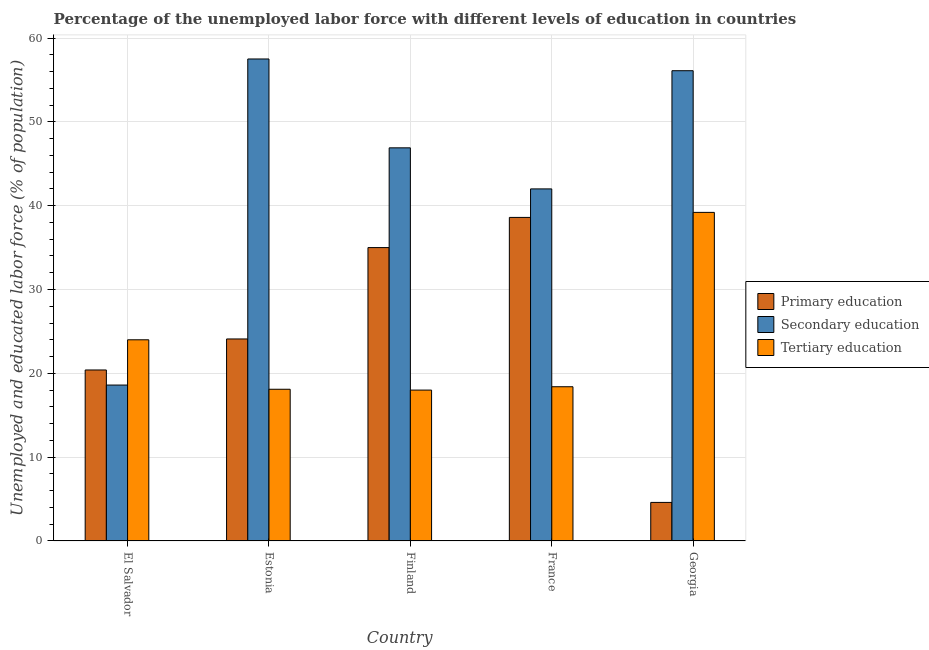Are the number of bars per tick equal to the number of legend labels?
Offer a very short reply. Yes. Are the number of bars on each tick of the X-axis equal?
Keep it short and to the point. Yes. How many bars are there on the 5th tick from the left?
Make the answer very short. 3. What is the label of the 1st group of bars from the left?
Give a very brief answer. El Salvador. What is the percentage of labor force who received secondary education in Georgia?
Provide a succinct answer. 56.1. Across all countries, what is the maximum percentage of labor force who received primary education?
Your answer should be compact. 38.6. In which country was the percentage of labor force who received primary education maximum?
Your response must be concise. France. In which country was the percentage of labor force who received tertiary education minimum?
Your answer should be very brief. Finland. What is the total percentage of labor force who received tertiary education in the graph?
Your response must be concise. 117.7. What is the difference between the percentage of labor force who received tertiary education in Estonia and that in Finland?
Your response must be concise. 0.1. What is the difference between the percentage of labor force who received secondary education in Georgia and the percentage of labor force who received primary education in France?
Give a very brief answer. 17.5. What is the average percentage of labor force who received tertiary education per country?
Your answer should be very brief. 23.54. What is the difference between the percentage of labor force who received secondary education and percentage of labor force who received tertiary education in Georgia?
Ensure brevity in your answer.  16.9. What is the ratio of the percentage of labor force who received secondary education in Estonia to that in France?
Provide a short and direct response. 1.37. What is the difference between the highest and the second highest percentage of labor force who received tertiary education?
Make the answer very short. 15.2. What is the difference between the highest and the lowest percentage of labor force who received tertiary education?
Offer a very short reply. 21.2. In how many countries, is the percentage of labor force who received secondary education greater than the average percentage of labor force who received secondary education taken over all countries?
Your answer should be very brief. 3. What does the 1st bar from the left in Georgia represents?
Make the answer very short. Primary education. Are all the bars in the graph horizontal?
Offer a very short reply. No. How many countries are there in the graph?
Provide a short and direct response. 5. What is the difference between two consecutive major ticks on the Y-axis?
Provide a succinct answer. 10. What is the title of the graph?
Your answer should be very brief. Percentage of the unemployed labor force with different levels of education in countries. Does "Profit Tax" appear as one of the legend labels in the graph?
Your response must be concise. No. What is the label or title of the X-axis?
Give a very brief answer. Country. What is the label or title of the Y-axis?
Provide a succinct answer. Unemployed and educated labor force (% of population). What is the Unemployed and educated labor force (% of population) in Primary education in El Salvador?
Keep it short and to the point. 20.4. What is the Unemployed and educated labor force (% of population) of Secondary education in El Salvador?
Provide a short and direct response. 18.6. What is the Unemployed and educated labor force (% of population) of Tertiary education in El Salvador?
Keep it short and to the point. 24. What is the Unemployed and educated labor force (% of population) in Primary education in Estonia?
Your answer should be very brief. 24.1. What is the Unemployed and educated labor force (% of population) of Secondary education in Estonia?
Provide a short and direct response. 57.5. What is the Unemployed and educated labor force (% of population) in Tertiary education in Estonia?
Offer a terse response. 18.1. What is the Unemployed and educated labor force (% of population) of Primary education in Finland?
Your answer should be compact. 35. What is the Unemployed and educated labor force (% of population) in Secondary education in Finland?
Your response must be concise. 46.9. What is the Unemployed and educated labor force (% of population) of Primary education in France?
Give a very brief answer. 38.6. What is the Unemployed and educated labor force (% of population) in Secondary education in France?
Your answer should be very brief. 42. What is the Unemployed and educated labor force (% of population) in Tertiary education in France?
Keep it short and to the point. 18.4. What is the Unemployed and educated labor force (% of population) of Primary education in Georgia?
Keep it short and to the point. 4.6. What is the Unemployed and educated labor force (% of population) in Secondary education in Georgia?
Offer a terse response. 56.1. What is the Unemployed and educated labor force (% of population) in Tertiary education in Georgia?
Provide a succinct answer. 39.2. Across all countries, what is the maximum Unemployed and educated labor force (% of population) in Primary education?
Keep it short and to the point. 38.6. Across all countries, what is the maximum Unemployed and educated labor force (% of population) in Secondary education?
Your response must be concise. 57.5. Across all countries, what is the maximum Unemployed and educated labor force (% of population) of Tertiary education?
Give a very brief answer. 39.2. Across all countries, what is the minimum Unemployed and educated labor force (% of population) of Primary education?
Offer a terse response. 4.6. Across all countries, what is the minimum Unemployed and educated labor force (% of population) in Secondary education?
Offer a very short reply. 18.6. Across all countries, what is the minimum Unemployed and educated labor force (% of population) in Tertiary education?
Offer a very short reply. 18. What is the total Unemployed and educated labor force (% of population) in Primary education in the graph?
Your answer should be compact. 122.7. What is the total Unemployed and educated labor force (% of population) of Secondary education in the graph?
Ensure brevity in your answer.  221.1. What is the total Unemployed and educated labor force (% of population) of Tertiary education in the graph?
Provide a succinct answer. 117.7. What is the difference between the Unemployed and educated labor force (% of population) in Primary education in El Salvador and that in Estonia?
Your response must be concise. -3.7. What is the difference between the Unemployed and educated labor force (% of population) of Secondary education in El Salvador and that in Estonia?
Give a very brief answer. -38.9. What is the difference between the Unemployed and educated labor force (% of population) of Tertiary education in El Salvador and that in Estonia?
Ensure brevity in your answer.  5.9. What is the difference between the Unemployed and educated labor force (% of population) of Primary education in El Salvador and that in Finland?
Ensure brevity in your answer.  -14.6. What is the difference between the Unemployed and educated labor force (% of population) of Secondary education in El Salvador and that in Finland?
Provide a short and direct response. -28.3. What is the difference between the Unemployed and educated labor force (% of population) in Primary education in El Salvador and that in France?
Make the answer very short. -18.2. What is the difference between the Unemployed and educated labor force (% of population) in Secondary education in El Salvador and that in France?
Keep it short and to the point. -23.4. What is the difference between the Unemployed and educated labor force (% of population) in Primary education in El Salvador and that in Georgia?
Ensure brevity in your answer.  15.8. What is the difference between the Unemployed and educated labor force (% of population) of Secondary education in El Salvador and that in Georgia?
Your answer should be very brief. -37.5. What is the difference between the Unemployed and educated labor force (% of population) in Tertiary education in El Salvador and that in Georgia?
Keep it short and to the point. -15.2. What is the difference between the Unemployed and educated labor force (% of population) of Primary education in Estonia and that in Finland?
Your answer should be very brief. -10.9. What is the difference between the Unemployed and educated labor force (% of population) of Secondary education in Estonia and that in France?
Your answer should be very brief. 15.5. What is the difference between the Unemployed and educated labor force (% of population) of Tertiary education in Estonia and that in France?
Your answer should be very brief. -0.3. What is the difference between the Unemployed and educated labor force (% of population) in Primary education in Estonia and that in Georgia?
Your response must be concise. 19.5. What is the difference between the Unemployed and educated labor force (% of population) of Tertiary education in Estonia and that in Georgia?
Give a very brief answer. -21.1. What is the difference between the Unemployed and educated labor force (% of population) in Secondary education in Finland and that in France?
Provide a short and direct response. 4.9. What is the difference between the Unemployed and educated labor force (% of population) of Tertiary education in Finland and that in France?
Provide a succinct answer. -0.4. What is the difference between the Unemployed and educated labor force (% of population) of Primary education in Finland and that in Georgia?
Your response must be concise. 30.4. What is the difference between the Unemployed and educated labor force (% of population) in Tertiary education in Finland and that in Georgia?
Your response must be concise. -21.2. What is the difference between the Unemployed and educated labor force (% of population) of Primary education in France and that in Georgia?
Your answer should be very brief. 34. What is the difference between the Unemployed and educated labor force (% of population) of Secondary education in France and that in Georgia?
Ensure brevity in your answer.  -14.1. What is the difference between the Unemployed and educated labor force (% of population) of Tertiary education in France and that in Georgia?
Your response must be concise. -20.8. What is the difference between the Unemployed and educated labor force (% of population) in Primary education in El Salvador and the Unemployed and educated labor force (% of population) in Secondary education in Estonia?
Offer a terse response. -37.1. What is the difference between the Unemployed and educated labor force (% of population) of Secondary education in El Salvador and the Unemployed and educated labor force (% of population) of Tertiary education in Estonia?
Provide a succinct answer. 0.5. What is the difference between the Unemployed and educated labor force (% of population) of Primary education in El Salvador and the Unemployed and educated labor force (% of population) of Secondary education in Finland?
Your answer should be compact. -26.5. What is the difference between the Unemployed and educated labor force (% of population) of Primary education in El Salvador and the Unemployed and educated labor force (% of population) of Secondary education in France?
Make the answer very short. -21.6. What is the difference between the Unemployed and educated labor force (% of population) of Primary education in El Salvador and the Unemployed and educated labor force (% of population) of Secondary education in Georgia?
Provide a short and direct response. -35.7. What is the difference between the Unemployed and educated labor force (% of population) of Primary education in El Salvador and the Unemployed and educated labor force (% of population) of Tertiary education in Georgia?
Keep it short and to the point. -18.8. What is the difference between the Unemployed and educated labor force (% of population) of Secondary education in El Salvador and the Unemployed and educated labor force (% of population) of Tertiary education in Georgia?
Provide a short and direct response. -20.6. What is the difference between the Unemployed and educated labor force (% of population) in Primary education in Estonia and the Unemployed and educated labor force (% of population) in Secondary education in Finland?
Your answer should be compact. -22.8. What is the difference between the Unemployed and educated labor force (% of population) in Secondary education in Estonia and the Unemployed and educated labor force (% of population) in Tertiary education in Finland?
Offer a terse response. 39.5. What is the difference between the Unemployed and educated labor force (% of population) of Primary education in Estonia and the Unemployed and educated labor force (% of population) of Secondary education in France?
Give a very brief answer. -17.9. What is the difference between the Unemployed and educated labor force (% of population) of Secondary education in Estonia and the Unemployed and educated labor force (% of population) of Tertiary education in France?
Your answer should be compact. 39.1. What is the difference between the Unemployed and educated labor force (% of population) of Primary education in Estonia and the Unemployed and educated labor force (% of population) of Secondary education in Georgia?
Offer a very short reply. -32. What is the difference between the Unemployed and educated labor force (% of population) in Primary education in Estonia and the Unemployed and educated labor force (% of population) in Tertiary education in Georgia?
Keep it short and to the point. -15.1. What is the difference between the Unemployed and educated labor force (% of population) of Secondary education in Estonia and the Unemployed and educated labor force (% of population) of Tertiary education in Georgia?
Offer a very short reply. 18.3. What is the difference between the Unemployed and educated labor force (% of population) of Secondary education in Finland and the Unemployed and educated labor force (% of population) of Tertiary education in France?
Provide a succinct answer. 28.5. What is the difference between the Unemployed and educated labor force (% of population) of Primary education in Finland and the Unemployed and educated labor force (% of population) of Secondary education in Georgia?
Keep it short and to the point. -21.1. What is the difference between the Unemployed and educated labor force (% of population) of Primary education in Finland and the Unemployed and educated labor force (% of population) of Tertiary education in Georgia?
Make the answer very short. -4.2. What is the difference between the Unemployed and educated labor force (% of population) in Secondary education in Finland and the Unemployed and educated labor force (% of population) in Tertiary education in Georgia?
Provide a succinct answer. 7.7. What is the difference between the Unemployed and educated labor force (% of population) in Primary education in France and the Unemployed and educated labor force (% of population) in Secondary education in Georgia?
Provide a succinct answer. -17.5. What is the average Unemployed and educated labor force (% of population) in Primary education per country?
Your response must be concise. 24.54. What is the average Unemployed and educated labor force (% of population) of Secondary education per country?
Provide a succinct answer. 44.22. What is the average Unemployed and educated labor force (% of population) in Tertiary education per country?
Provide a short and direct response. 23.54. What is the difference between the Unemployed and educated labor force (% of population) in Primary education and Unemployed and educated labor force (% of population) in Secondary education in El Salvador?
Your response must be concise. 1.8. What is the difference between the Unemployed and educated labor force (% of population) of Primary education and Unemployed and educated labor force (% of population) of Tertiary education in El Salvador?
Your response must be concise. -3.6. What is the difference between the Unemployed and educated labor force (% of population) in Secondary education and Unemployed and educated labor force (% of population) in Tertiary education in El Salvador?
Your answer should be very brief. -5.4. What is the difference between the Unemployed and educated labor force (% of population) in Primary education and Unemployed and educated labor force (% of population) in Secondary education in Estonia?
Your answer should be very brief. -33.4. What is the difference between the Unemployed and educated labor force (% of population) in Secondary education and Unemployed and educated labor force (% of population) in Tertiary education in Estonia?
Give a very brief answer. 39.4. What is the difference between the Unemployed and educated labor force (% of population) of Secondary education and Unemployed and educated labor force (% of population) of Tertiary education in Finland?
Give a very brief answer. 28.9. What is the difference between the Unemployed and educated labor force (% of population) in Primary education and Unemployed and educated labor force (% of population) in Secondary education in France?
Provide a short and direct response. -3.4. What is the difference between the Unemployed and educated labor force (% of population) of Primary education and Unemployed and educated labor force (% of population) of Tertiary education in France?
Provide a short and direct response. 20.2. What is the difference between the Unemployed and educated labor force (% of population) of Secondary education and Unemployed and educated labor force (% of population) of Tertiary education in France?
Your answer should be very brief. 23.6. What is the difference between the Unemployed and educated labor force (% of population) in Primary education and Unemployed and educated labor force (% of population) in Secondary education in Georgia?
Make the answer very short. -51.5. What is the difference between the Unemployed and educated labor force (% of population) in Primary education and Unemployed and educated labor force (% of population) in Tertiary education in Georgia?
Provide a succinct answer. -34.6. What is the difference between the Unemployed and educated labor force (% of population) of Secondary education and Unemployed and educated labor force (% of population) of Tertiary education in Georgia?
Make the answer very short. 16.9. What is the ratio of the Unemployed and educated labor force (% of population) of Primary education in El Salvador to that in Estonia?
Your response must be concise. 0.85. What is the ratio of the Unemployed and educated labor force (% of population) in Secondary education in El Salvador to that in Estonia?
Your answer should be very brief. 0.32. What is the ratio of the Unemployed and educated labor force (% of population) of Tertiary education in El Salvador to that in Estonia?
Provide a succinct answer. 1.33. What is the ratio of the Unemployed and educated labor force (% of population) of Primary education in El Salvador to that in Finland?
Make the answer very short. 0.58. What is the ratio of the Unemployed and educated labor force (% of population) of Secondary education in El Salvador to that in Finland?
Provide a succinct answer. 0.4. What is the ratio of the Unemployed and educated labor force (% of population) of Primary education in El Salvador to that in France?
Offer a terse response. 0.53. What is the ratio of the Unemployed and educated labor force (% of population) of Secondary education in El Salvador to that in France?
Your answer should be compact. 0.44. What is the ratio of the Unemployed and educated labor force (% of population) in Tertiary education in El Salvador to that in France?
Ensure brevity in your answer.  1.3. What is the ratio of the Unemployed and educated labor force (% of population) of Primary education in El Salvador to that in Georgia?
Provide a short and direct response. 4.43. What is the ratio of the Unemployed and educated labor force (% of population) in Secondary education in El Salvador to that in Georgia?
Ensure brevity in your answer.  0.33. What is the ratio of the Unemployed and educated labor force (% of population) of Tertiary education in El Salvador to that in Georgia?
Make the answer very short. 0.61. What is the ratio of the Unemployed and educated labor force (% of population) of Primary education in Estonia to that in Finland?
Provide a short and direct response. 0.69. What is the ratio of the Unemployed and educated labor force (% of population) in Secondary education in Estonia to that in Finland?
Ensure brevity in your answer.  1.23. What is the ratio of the Unemployed and educated labor force (% of population) of Tertiary education in Estonia to that in Finland?
Give a very brief answer. 1.01. What is the ratio of the Unemployed and educated labor force (% of population) of Primary education in Estonia to that in France?
Give a very brief answer. 0.62. What is the ratio of the Unemployed and educated labor force (% of population) in Secondary education in Estonia to that in France?
Provide a short and direct response. 1.37. What is the ratio of the Unemployed and educated labor force (% of population) of Tertiary education in Estonia to that in France?
Make the answer very short. 0.98. What is the ratio of the Unemployed and educated labor force (% of population) in Primary education in Estonia to that in Georgia?
Ensure brevity in your answer.  5.24. What is the ratio of the Unemployed and educated labor force (% of population) of Tertiary education in Estonia to that in Georgia?
Offer a terse response. 0.46. What is the ratio of the Unemployed and educated labor force (% of population) of Primary education in Finland to that in France?
Provide a short and direct response. 0.91. What is the ratio of the Unemployed and educated labor force (% of population) in Secondary education in Finland to that in France?
Give a very brief answer. 1.12. What is the ratio of the Unemployed and educated labor force (% of population) of Tertiary education in Finland to that in France?
Provide a short and direct response. 0.98. What is the ratio of the Unemployed and educated labor force (% of population) in Primary education in Finland to that in Georgia?
Your answer should be very brief. 7.61. What is the ratio of the Unemployed and educated labor force (% of population) in Secondary education in Finland to that in Georgia?
Your response must be concise. 0.84. What is the ratio of the Unemployed and educated labor force (% of population) in Tertiary education in Finland to that in Georgia?
Your answer should be compact. 0.46. What is the ratio of the Unemployed and educated labor force (% of population) of Primary education in France to that in Georgia?
Provide a succinct answer. 8.39. What is the ratio of the Unemployed and educated labor force (% of population) in Secondary education in France to that in Georgia?
Ensure brevity in your answer.  0.75. What is the ratio of the Unemployed and educated labor force (% of population) in Tertiary education in France to that in Georgia?
Provide a short and direct response. 0.47. What is the difference between the highest and the lowest Unemployed and educated labor force (% of population) of Secondary education?
Ensure brevity in your answer.  38.9. What is the difference between the highest and the lowest Unemployed and educated labor force (% of population) of Tertiary education?
Your answer should be compact. 21.2. 